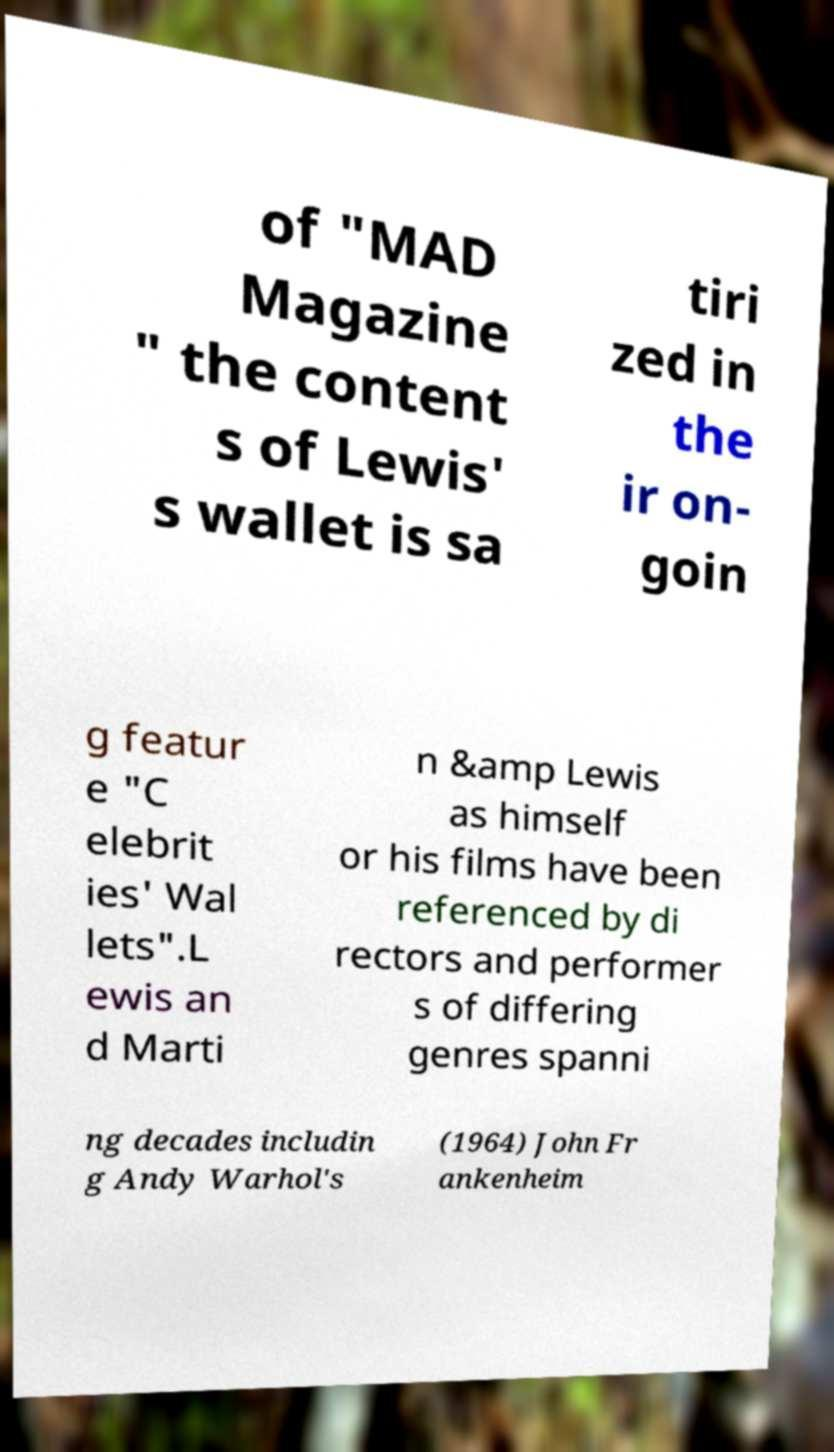Please identify and transcribe the text found in this image. of "MAD Magazine " the content s of Lewis' s wallet is sa tiri zed in the ir on- goin g featur e "C elebrit ies' Wal lets".L ewis an d Marti n &amp Lewis as himself or his films have been referenced by di rectors and performer s of differing genres spanni ng decades includin g Andy Warhol's (1964) John Fr ankenheim 